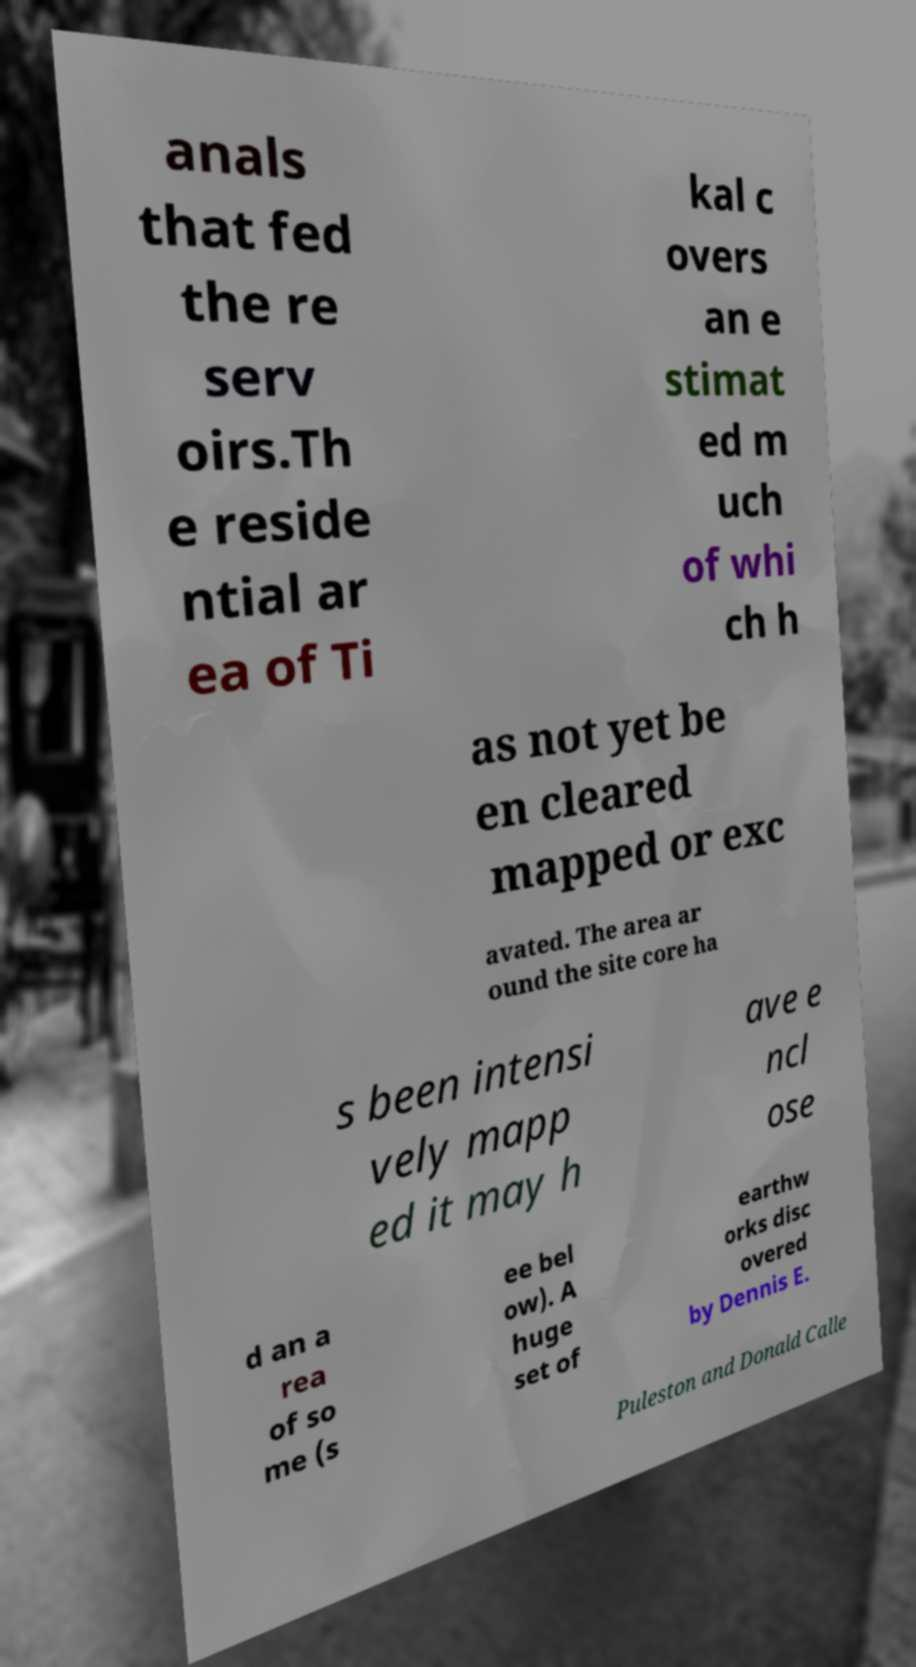Please identify and transcribe the text found in this image. anals that fed the re serv oirs.Th e reside ntial ar ea of Ti kal c overs an e stimat ed m uch of whi ch h as not yet be en cleared mapped or exc avated. The area ar ound the site core ha s been intensi vely mapp ed it may h ave e ncl ose d an a rea of so me (s ee bel ow). A huge set of earthw orks disc overed by Dennis E. Puleston and Donald Calle 